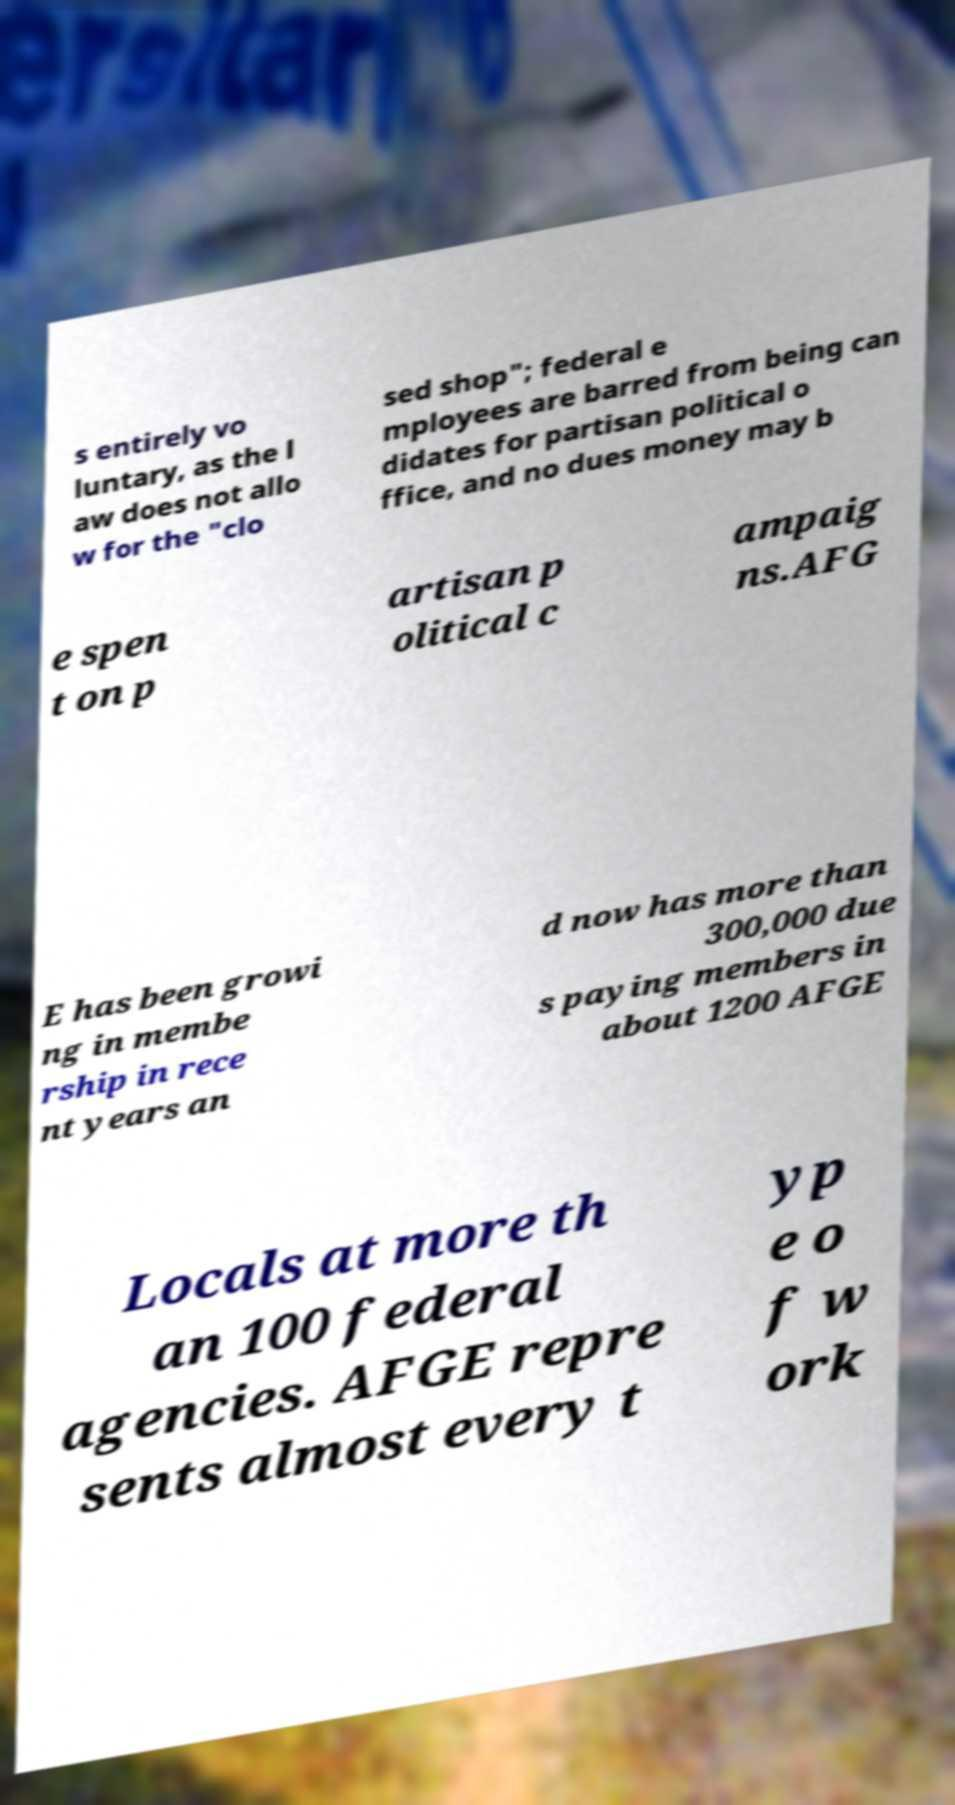Please identify and transcribe the text found in this image. s entirely vo luntary, as the l aw does not allo w for the "clo sed shop"; federal e mployees are barred from being can didates for partisan political o ffice, and no dues money may b e spen t on p artisan p olitical c ampaig ns.AFG E has been growi ng in membe rship in rece nt years an d now has more than 300,000 due s paying members in about 1200 AFGE Locals at more th an 100 federal agencies. AFGE repre sents almost every t yp e o f w ork 